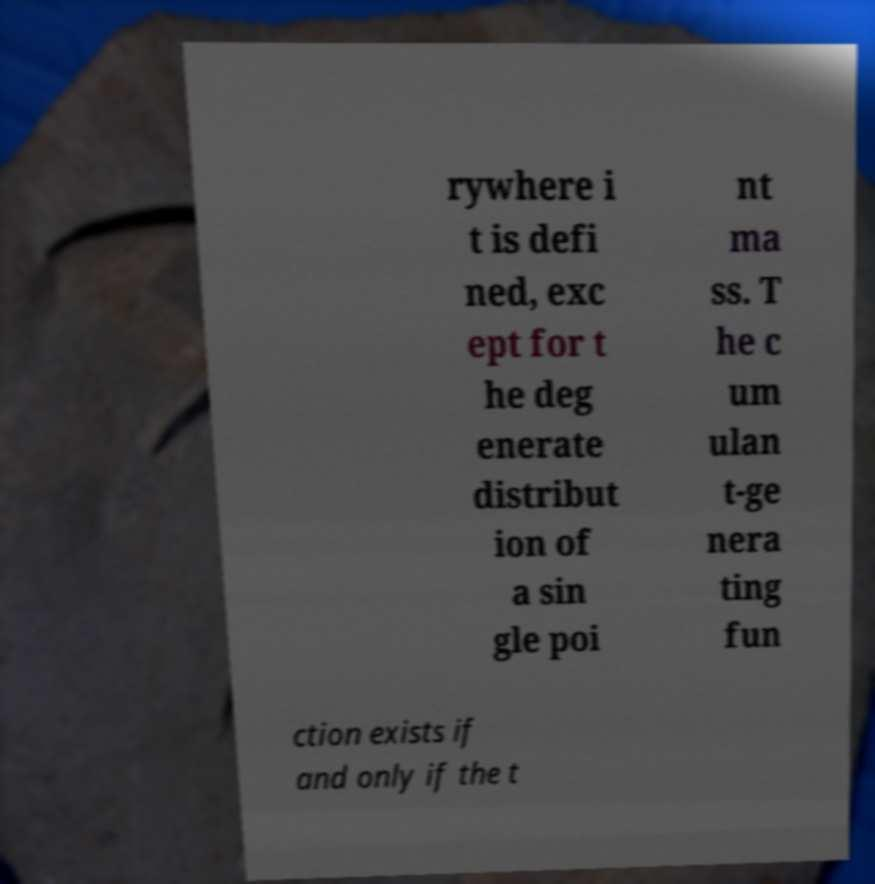Can you read and provide the text displayed in the image?This photo seems to have some interesting text. Can you extract and type it out for me? rywhere i t is defi ned, exc ept for t he deg enerate distribut ion of a sin gle poi nt ma ss. T he c um ulan t-ge nera ting fun ction exists if and only if the t 